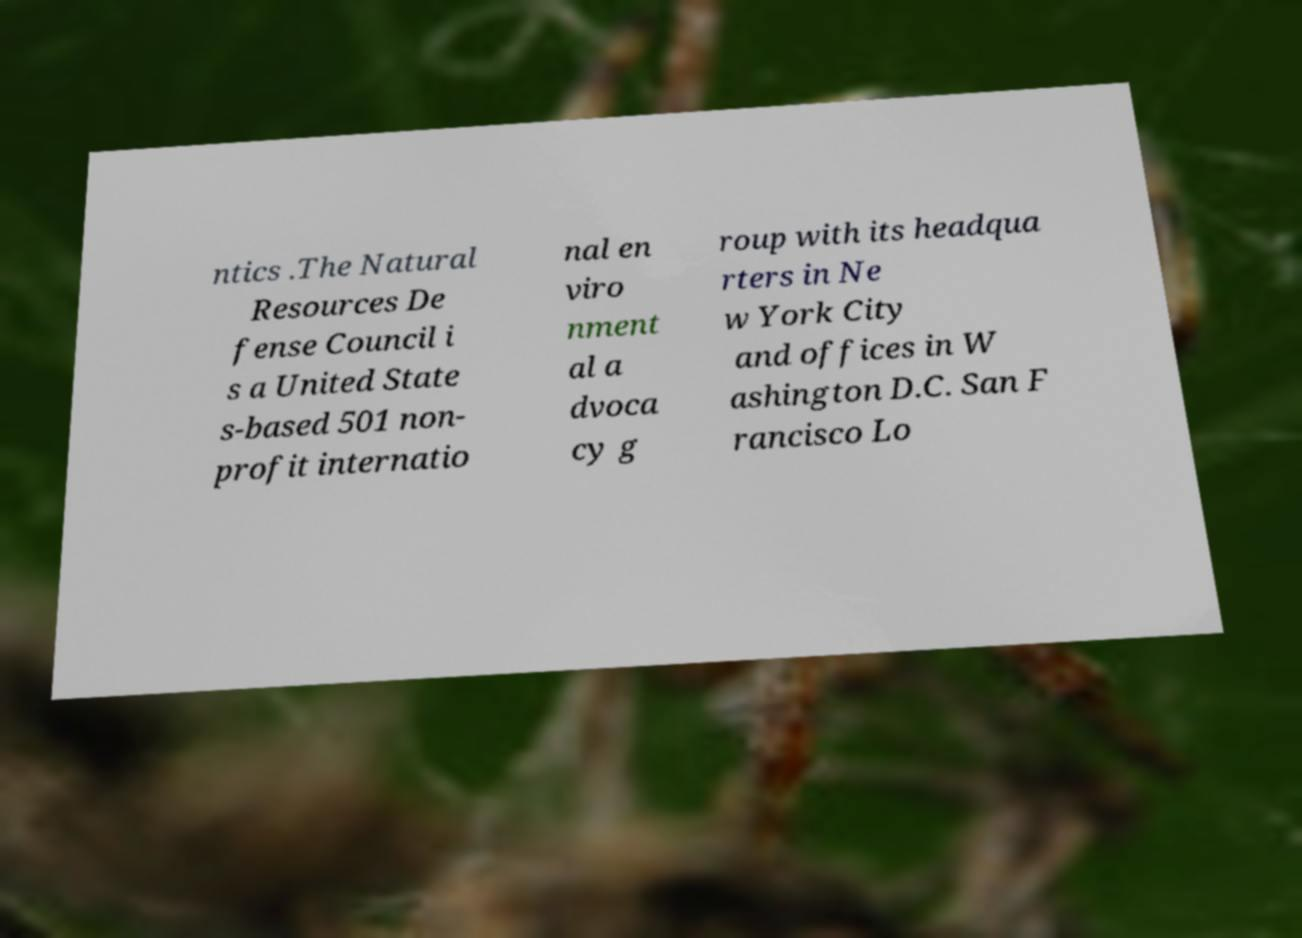Could you extract and type out the text from this image? ntics .The Natural Resources De fense Council i s a United State s-based 501 non- profit internatio nal en viro nment al a dvoca cy g roup with its headqua rters in Ne w York City and offices in W ashington D.C. San F rancisco Lo 